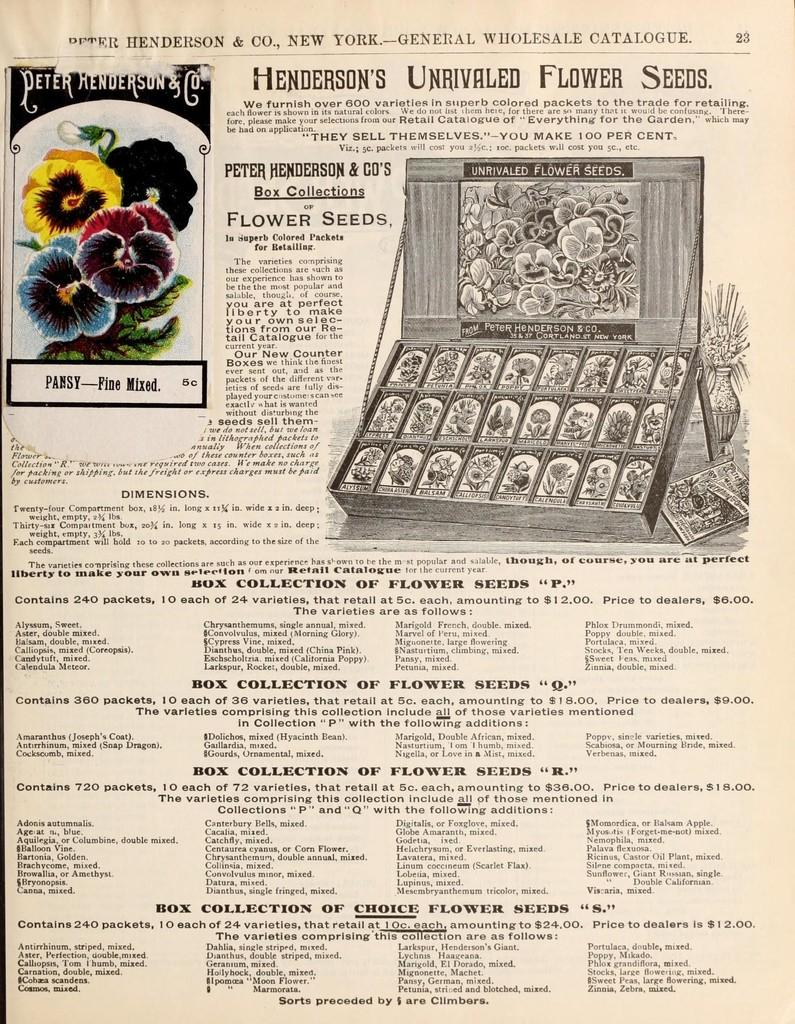What type of living organisms can be seen in the image? There are flowers depicted in the image. What else is present in the image besides the flowers? There is text written in the image. Can you hear the guitar playing in the image? There is no mention of a guitar or any sound in the image. 